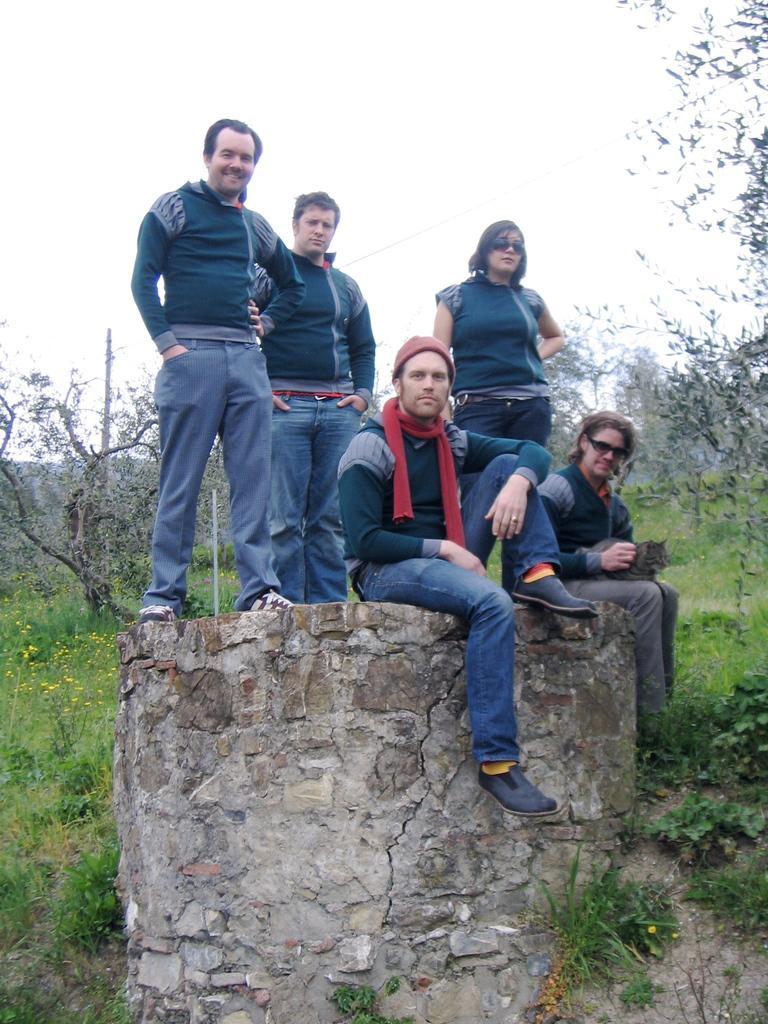How would you summarize this image in a sentence or two? In this image I can see five persons where two are sitting and three are standing. I can also see they all are wearing same colour of dress. In the background I can see grass, flowers and number of trees. 